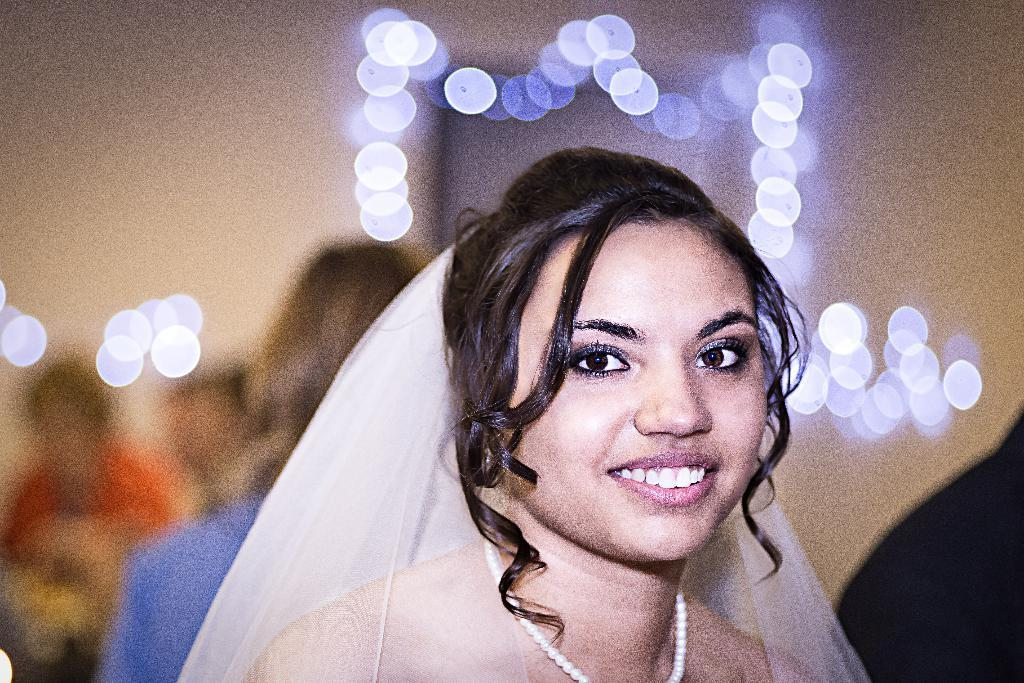Who is present in the image? There is a woman in the image. What is the woman's expression? The woman is smiling. Can you describe the background of the image? The background of the image is blurred. Are there any other people visible in the image? Yes, there are people in the background of the image. What can be seen in terms of lighting? There are lights visible in the image. What type of blade is being used in the war depicted in the image? There is no war or blade present in the image; it features a woman smiling with a blurred background and lights visible. 